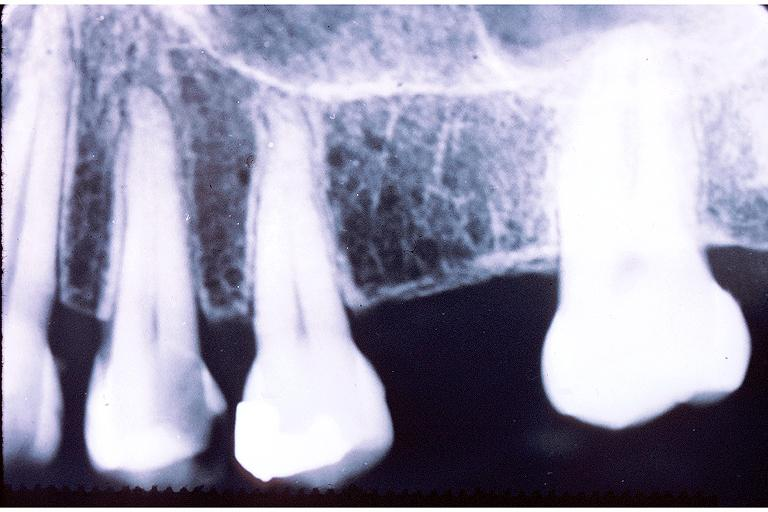does this image show caries?
Answer the question using a single word or phrase. Yes 